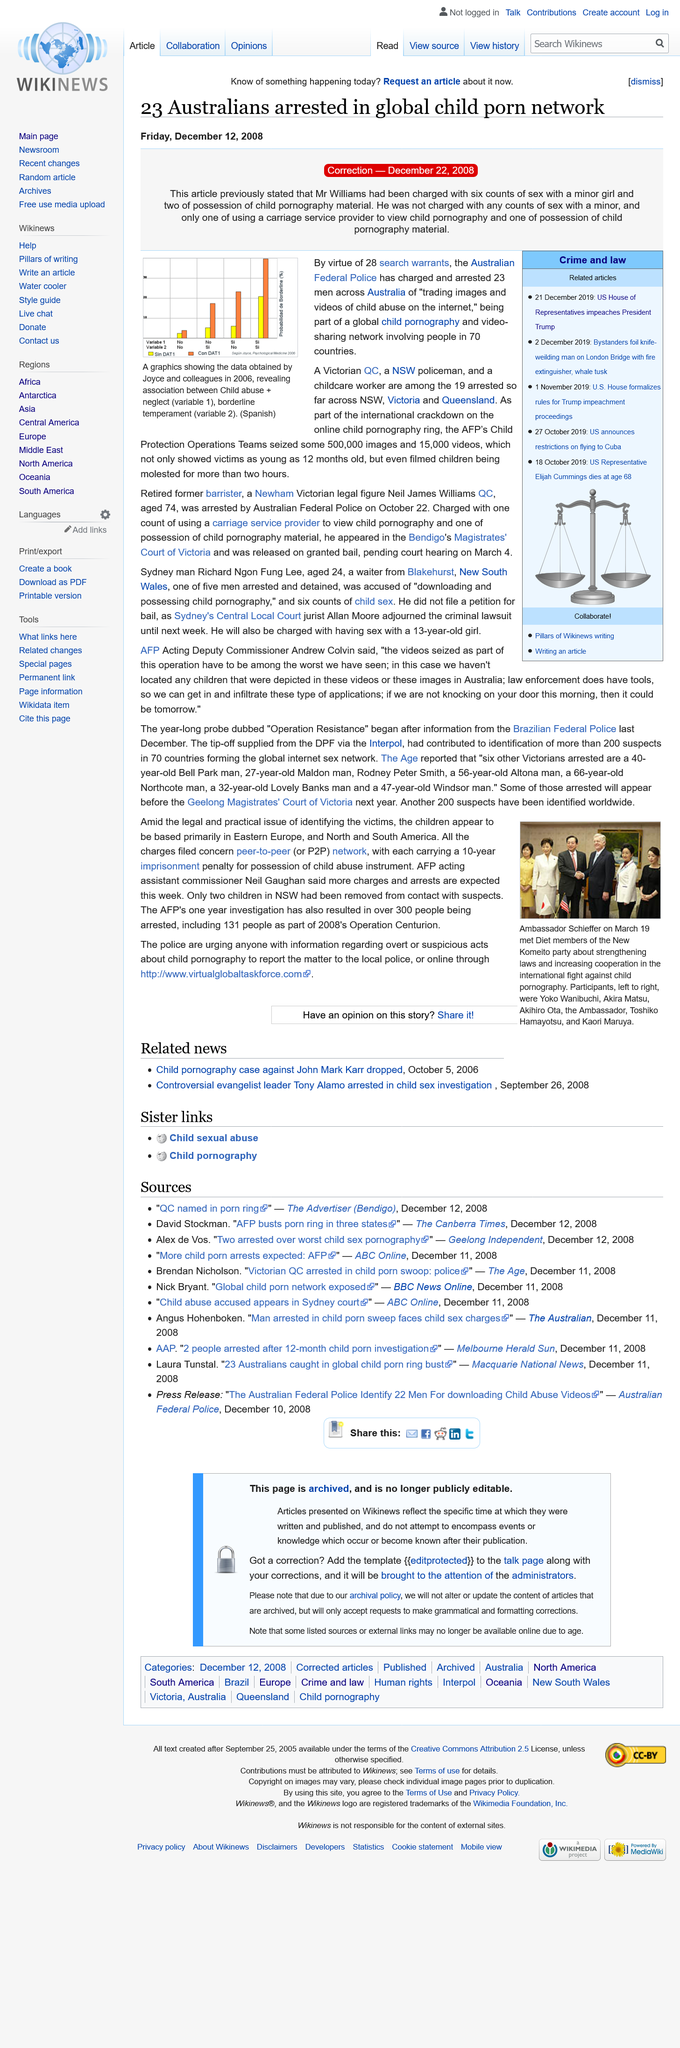List a handful of essential elements in this visual. A total of 23 men were arrested and charged in connection to the crime. There were a total of 28 search warrants. The AFP's Child Protection Operations Teams seized approximately 500,000 images as part of their efforts to protect children from harm. 